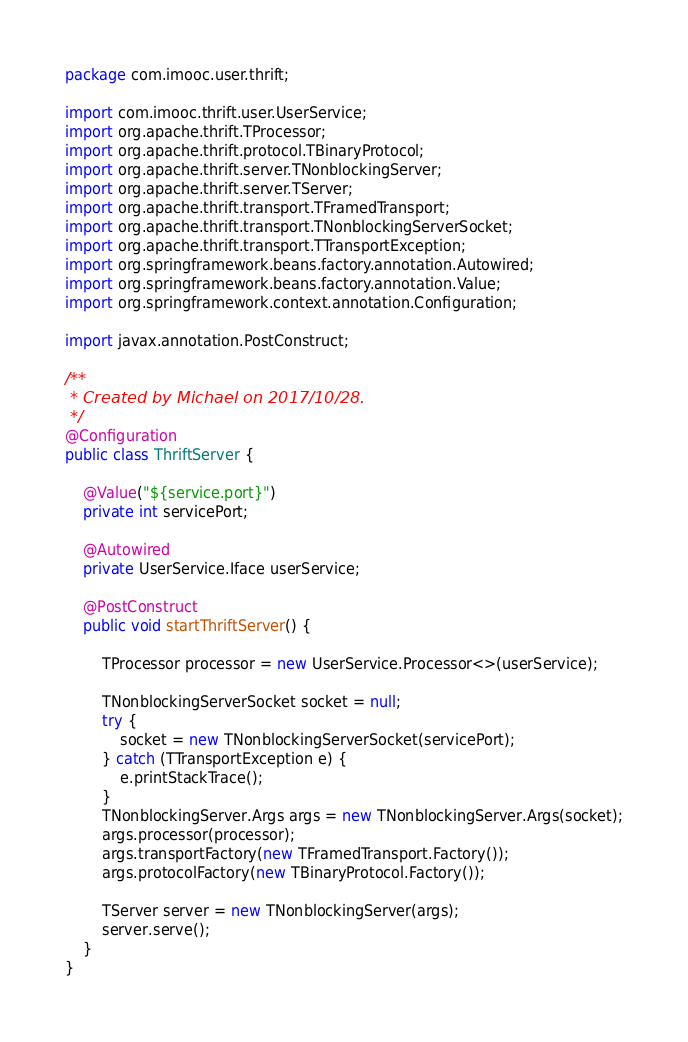Convert code to text. <code><loc_0><loc_0><loc_500><loc_500><_Java_>package com.imooc.user.thrift;

import com.imooc.thrift.user.UserService;
import org.apache.thrift.TProcessor;
import org.apache.thrift.protocol.TBinaryProtocol;
import org.apache.thrift.server.TNonblockingServer;
import org.apache.thrift.server.TServer;
import org.apache.thrift.transport.TFramedTransport;
import org.apache.thrift.transport.TNonblockingServerSocket;
import org.apache.thrift.transport.TTransportException;
import org.springframework.beans.factory.annotation.Autowired;
import org.springframework.beans.factory.annotation.Value;
import org.springframework.context.annotation.Configuration;

import javax.annotation.PostConstruct;

/**
 * Created by Michael on 2017/10/28.
 */
@Configuration
public class ThriftServer {

    @Value("${service.port}")
    private int servicePort;

    @Autowired
    private UserService.Iface userService;

    @PostConstruct
    public void startThriftServer() {

        TProcessor processor = new UserService.Processor<>(userService);

        TNonblockingServerSocket socket = null;
        try {
            socket = new TNonblockingServerSocket(servicePort);
        } catch (TTransportException e) {
            e.printStackTrace();
        }
        TNonblockingServer.Args args = new TNonblockingServer.Args(socket);
        args.processor(processor);
        args.transportFactory(new TFramedTransport.Factory());
        args.protocolFactory(new TBinaryProtocol.Factory());

        TServer server = new TNonblockingServer(args);
        server.serve();
    }
}
</code> 